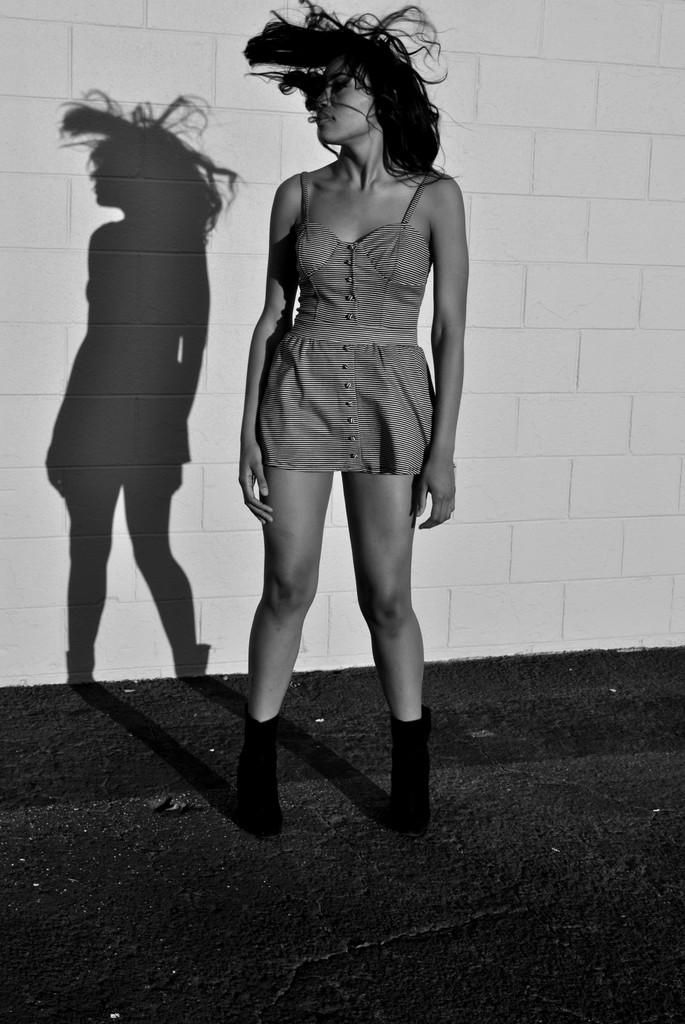What is the color scheme of the image? The image is black and white. Can you describe the person in the image? There is a lady standing in the image. What can be seen in the background of the image? There is a shadow on the wall in the background. What is visible at the bottom of the image? There is a road visible at the bottom of the image. What type of trouble is the lady experiencing in the image? There is no indication of trouble in the image; it simply shows a lady standing. Can you tell me how many committee members are present in the image? There are no committee members present in the image. 